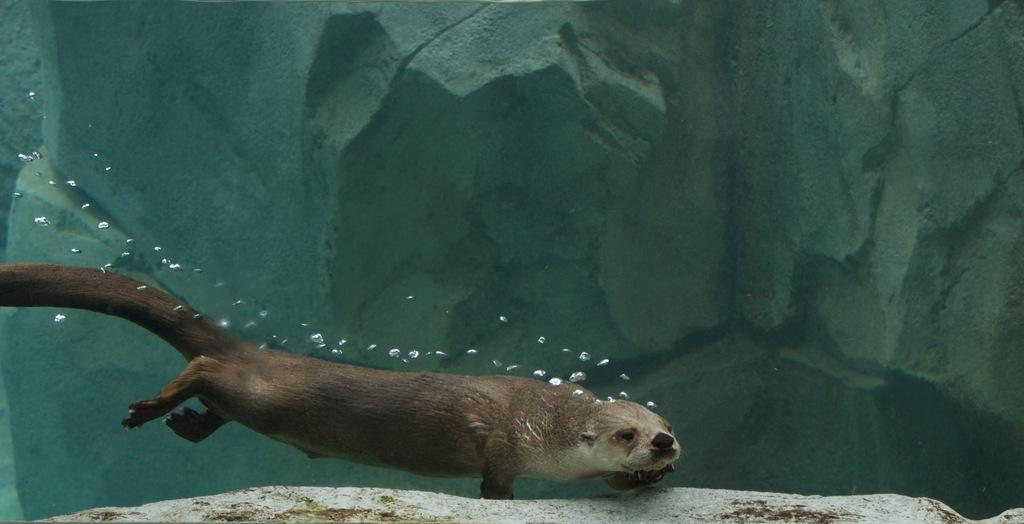What is the main subject of the image? There is an animal in the water. Can you describe the animal's location in the image? The animal is in the water. What type of environment is depicted in the image? The image shows a water environment. What is the fifth animal doing on the coast in the image? There is no fifth animal or coast present in the image; it only features an animal in the water. 